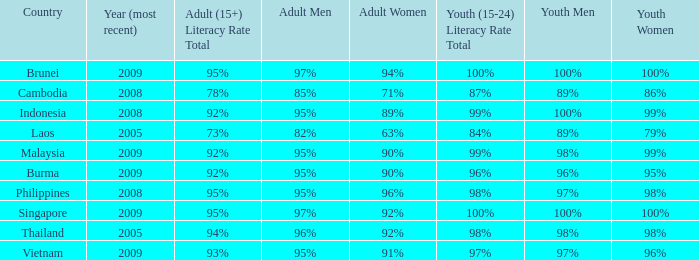Which country has a Youth (15-24) Literacy Rate Total of 100% and has an Adult Women Literacy rate of 92%? Singapore. 